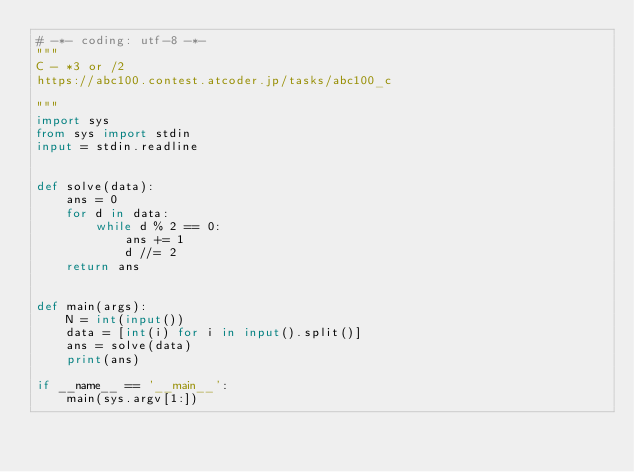<code> <loc_0><loc_0><loc_500><loc_500><_Python_># -*- coding: utf-8 -*-
"""
C - *3 or /2
https://abc100.contest.atcoder.jp/tasks/abc100_c

"""
import sys
from sys import stdin
input = stdin.readline


def solve(data):
    ans = 0
    for d in data:
        while d % 2 == 0:
            ans += 1
            d //= 2
    return ans


def main(args):
    N = int(input())
    data = [int(i) for i in input().split()]
    ans = solve(data)
    print(ans)

if __name__ == '__main__':
    main(sys.argv[1:])
</code> 